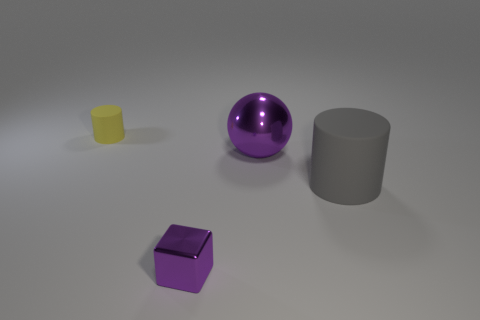Can you describe the lighting in the scene? The lighting in the scene appears to be soft and diffused, providing an even illumination across the objects without causing any harsh shadows. It's likely that the light source is positioned above the objects, slightly off to the left, as suggested by the subtle shadows. 